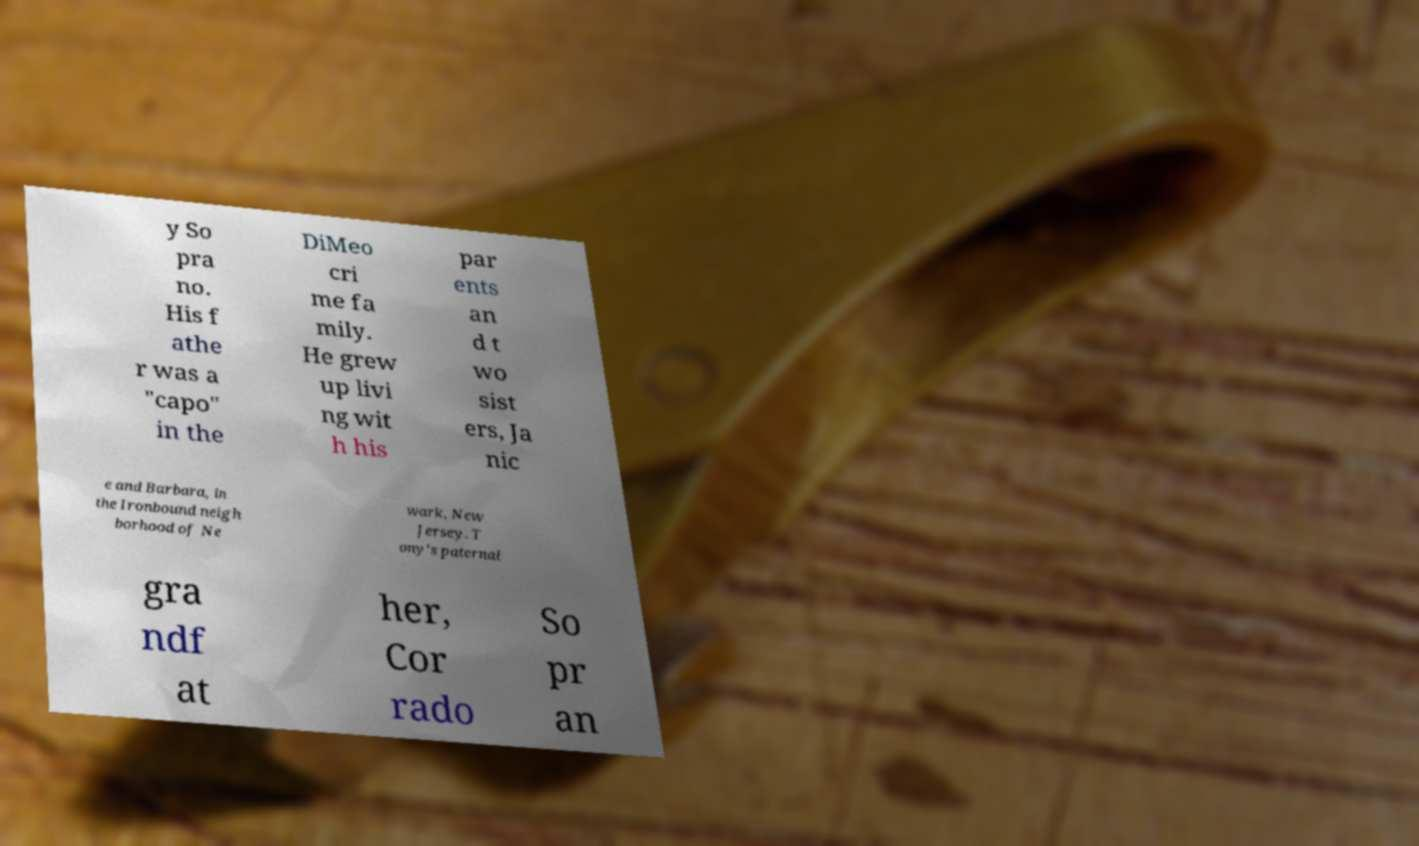Can you accurately transcribe the text from the provided image for me? y So pra no. His f athe r was a "capo" in the DiMeo cri me fa mily. He grew up livi ng wit h his par ents an d t wo sist ers, Ja nic e and Barbara, in the Ironbound neigh borhood of Ne wark, New Jersey. T ony's paternal gra ndf at her, Cor rado So pr an 